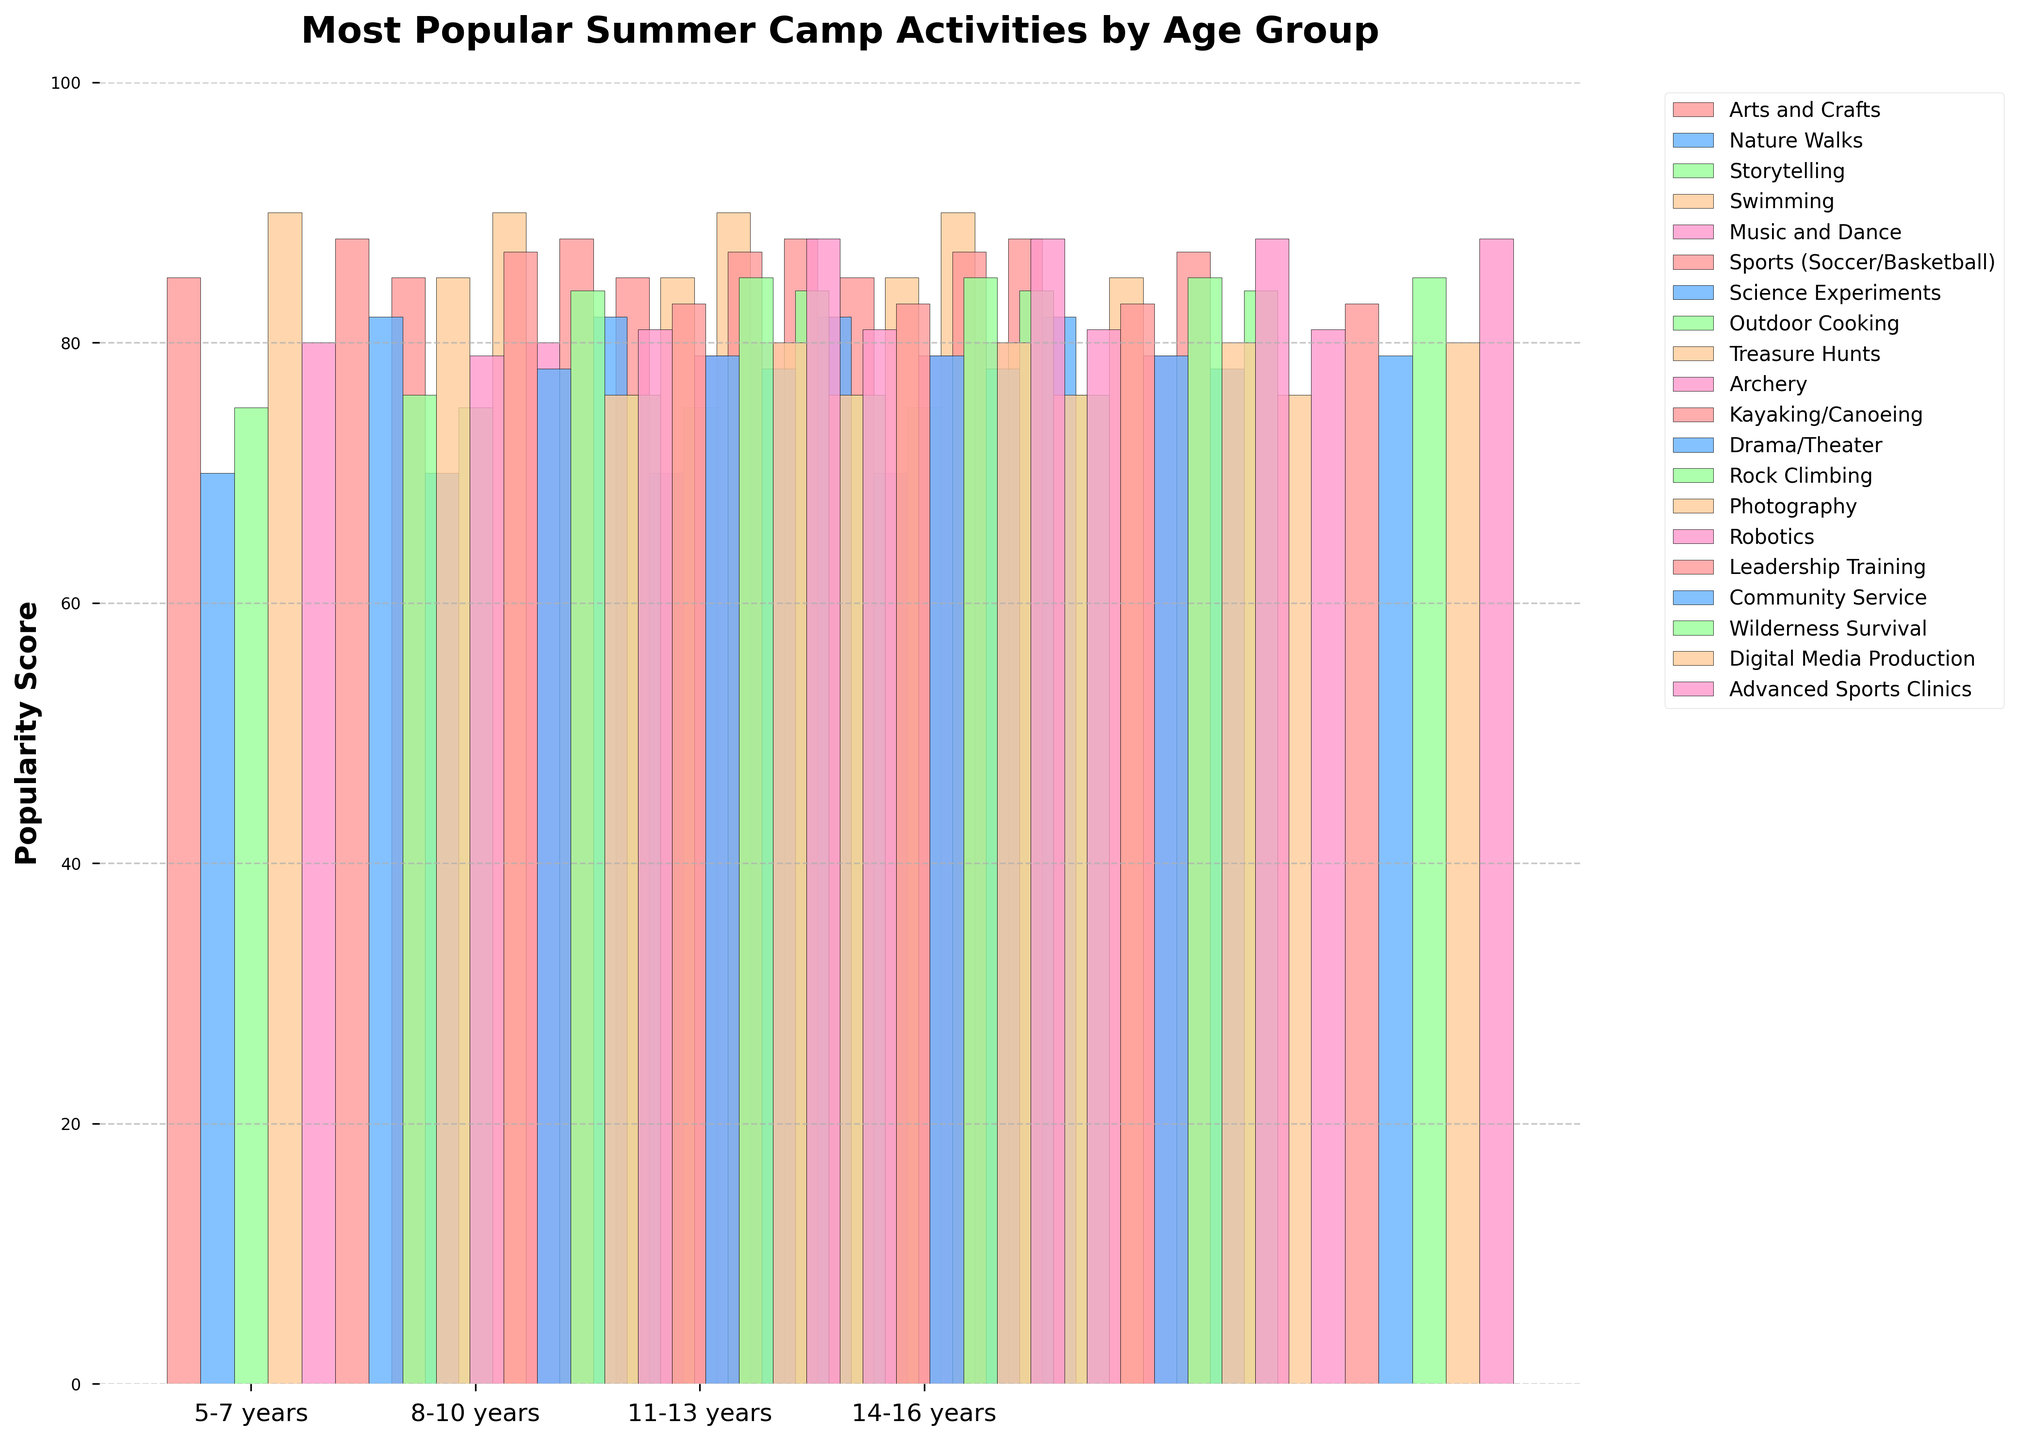Which activity is the most popular among 5-7 years age group? The popularity score for each activity is listed, and the activity with the highest score of 90 in this group is Swimming
Answer: Swimming Which age group has the highest average popularity score for their activities? Calculate the average popularity score for each age group by summing their scores and dividing by the number of activities. Compare averages 5-7: (85+70+75+90+80)/5 = 80, 8-10: (88+82+76+85+79)/5 = 82, 11-13: (87+78+84+76+81)/5 = 81.2, 14-16: (83+79+85+80+88)/5 = 83. The highest average score is 83 for the age group 14-16 years
Answer: 14-16 years Which two activities have the closest popularity scores within any single age group, and what is this score difference? Look for activities within the same age group with the smallest difference in scores. For 5-7 years, Nature Walks (70) and Storytelling (75) differ by 5. For 8-10 years, Outdoor Cooking (76) and Archery (79) differ by 3. For 11-13 years, Photography (76) and Drama/Theater (78) differ by 2. For 14-16 years, Digital Media Production (80) and Community Service (79) differ by 1
Answer: Digital Media Production and Community Service in 14-16 years with a score difference of 1 Which activity has the second highest popularity score in the 8-10 years age group? Organize the popularity scores of the 8-10 years group's activities in descending order. The second highest score after Sports (88) is Treasure Hunts with 85
Answer: Treasure Hunts How many activities in the 11-13 years age group have a popularity score above 80? Identify the activities and their scores. Kayaking/Canoeing (87), Rock Climbing (84), and Robotics (81) are above 80. The count is 3
Answer: 3 